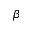<formula> <loc_0><loc_0><loc_500><loc_500>\beta</formula> 